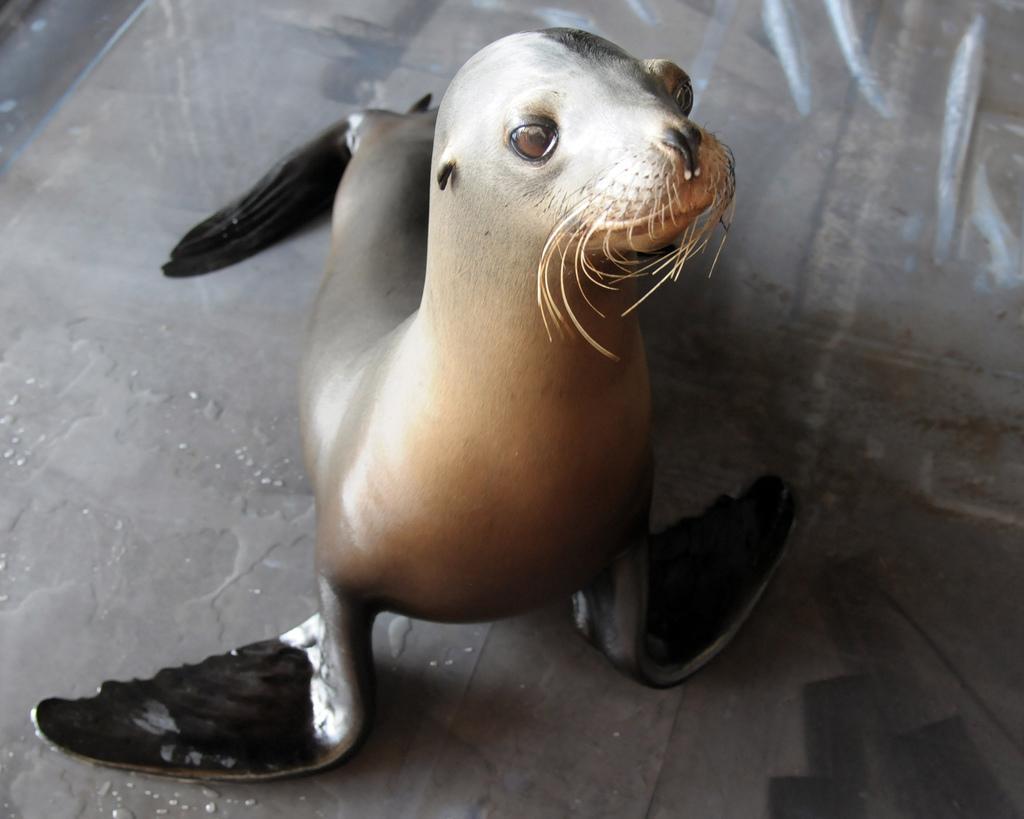How would you summarize this image in a sentence or two? In this image we can see a navy marine mammal program sea lion on the floor, which is brown and black color combination. 